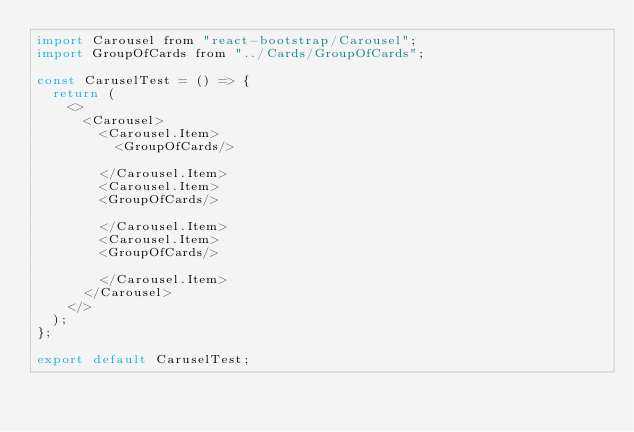<code> <loc_0><loc_0><loc_500><loc_500><_JavaScript_>import Carousel from "react-bootstrap/Carousel";
import GroupOfCards from "../Cards/GroupOfCards";

const CaruselTest = () => {
  return (
    <>
      <Carousel>
        <Carousel.Item>
          <GroupOfCards/>
          
        </Carousel.Item>
        <Carousel.Item>
        <GroupOfCards/>
          
        </Carousel.Item>
        <Carousel.Item>
        <GroupOfCards/>
          
        </Carousel.Item>
      </Carousel>      
    </>
  );
};

export default CaruselTest;
</code> 